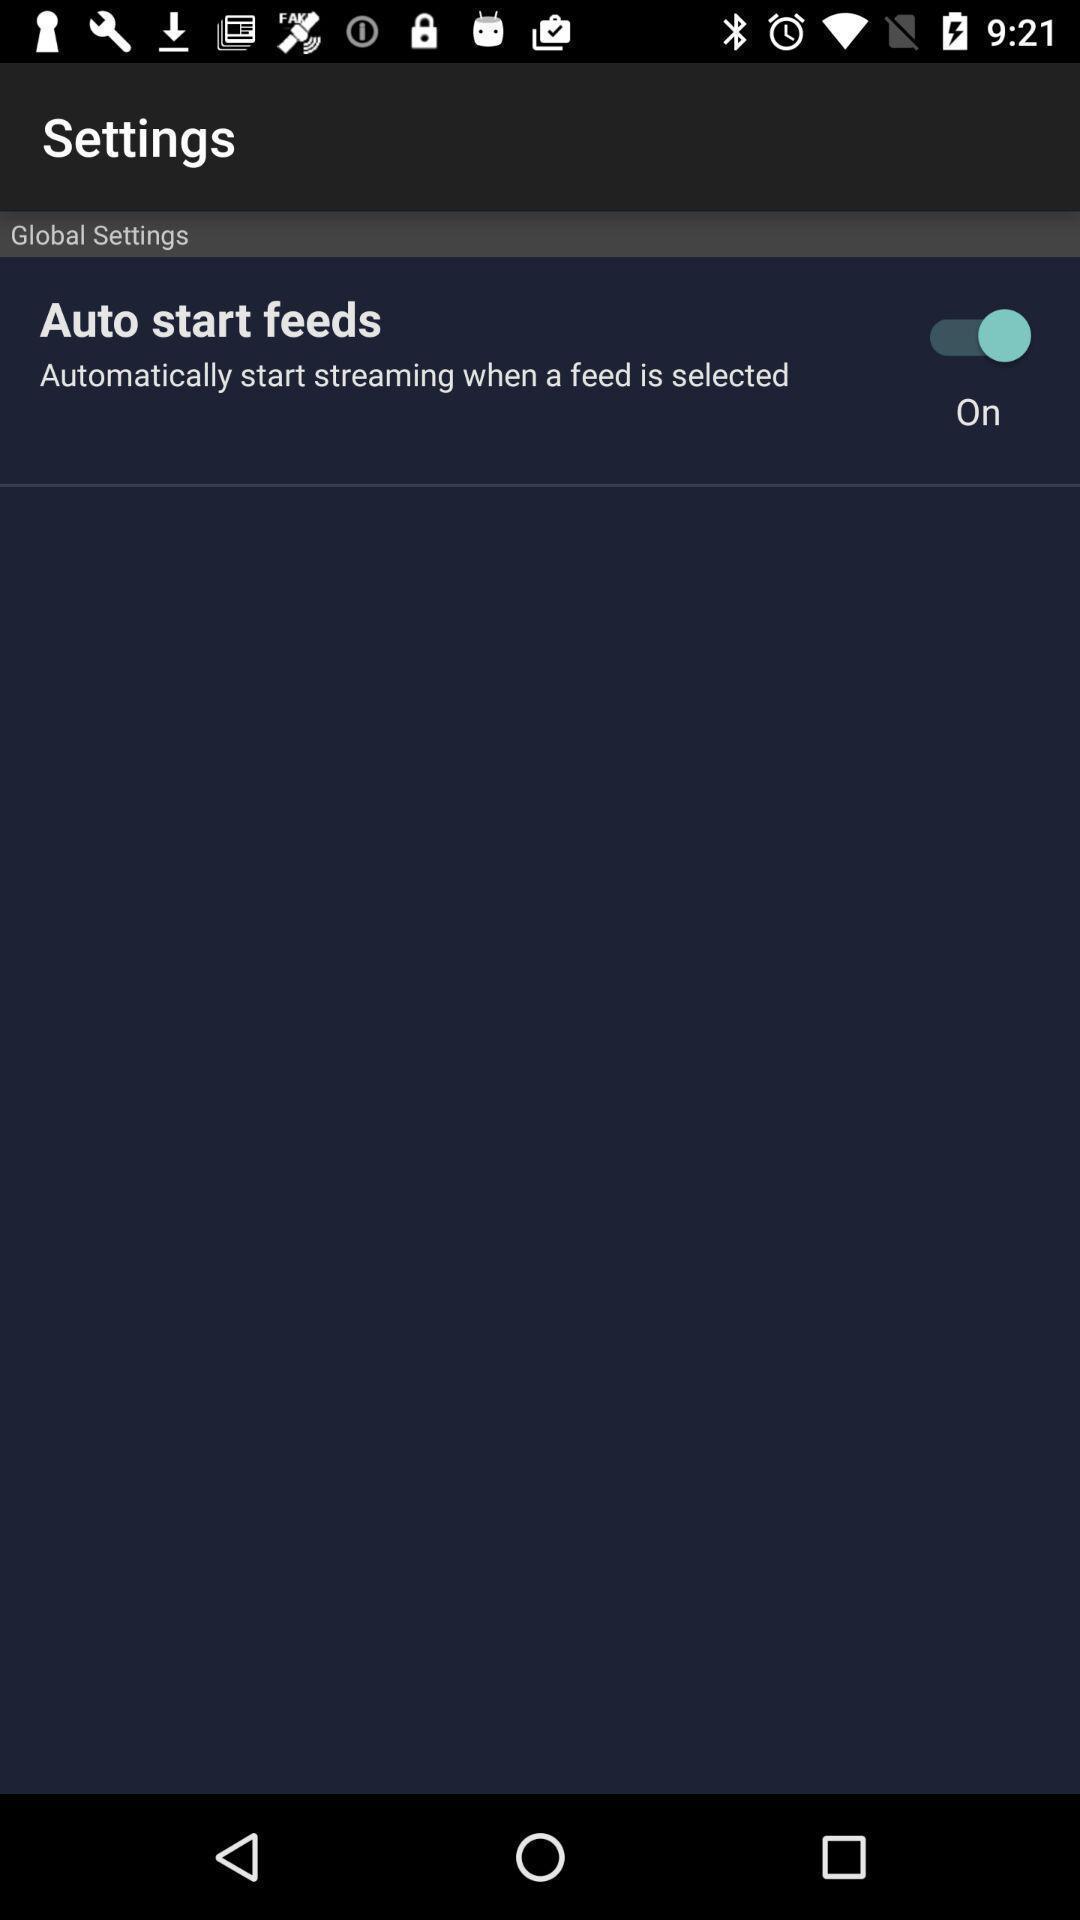Describe the content in this image. Settings page displaying. 